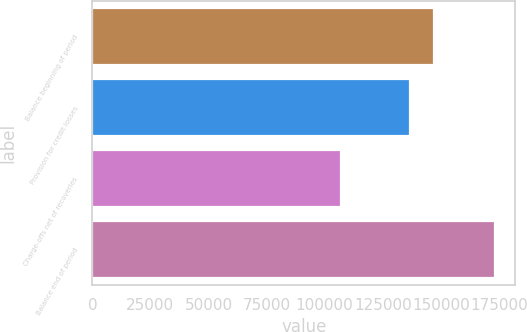Convert chart. <chart><loc_0><loc_0><loc_500><loc_500><bar_chart><fcel>Balance beginning of period<fcel>Provision for credit losses<fcel>Charge-offs net of recoveries<fcel>Balance end of period<nl><fcel>147178<fcel>136617<fcel>107161<fcel>173343<nl></chart> 